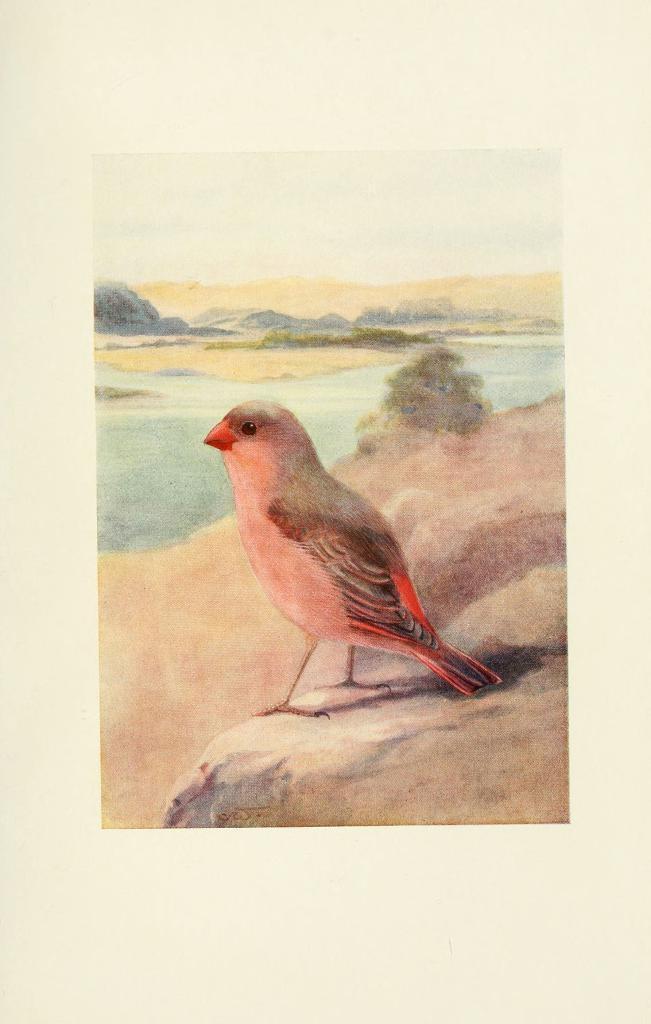Please provide a concise description of this image. This picture is painting. In the center of the image we can see a bird. In the middle of the image water, trees, mountains are present. At the bottom of the image ground is there. At the top of the image sky is present. 